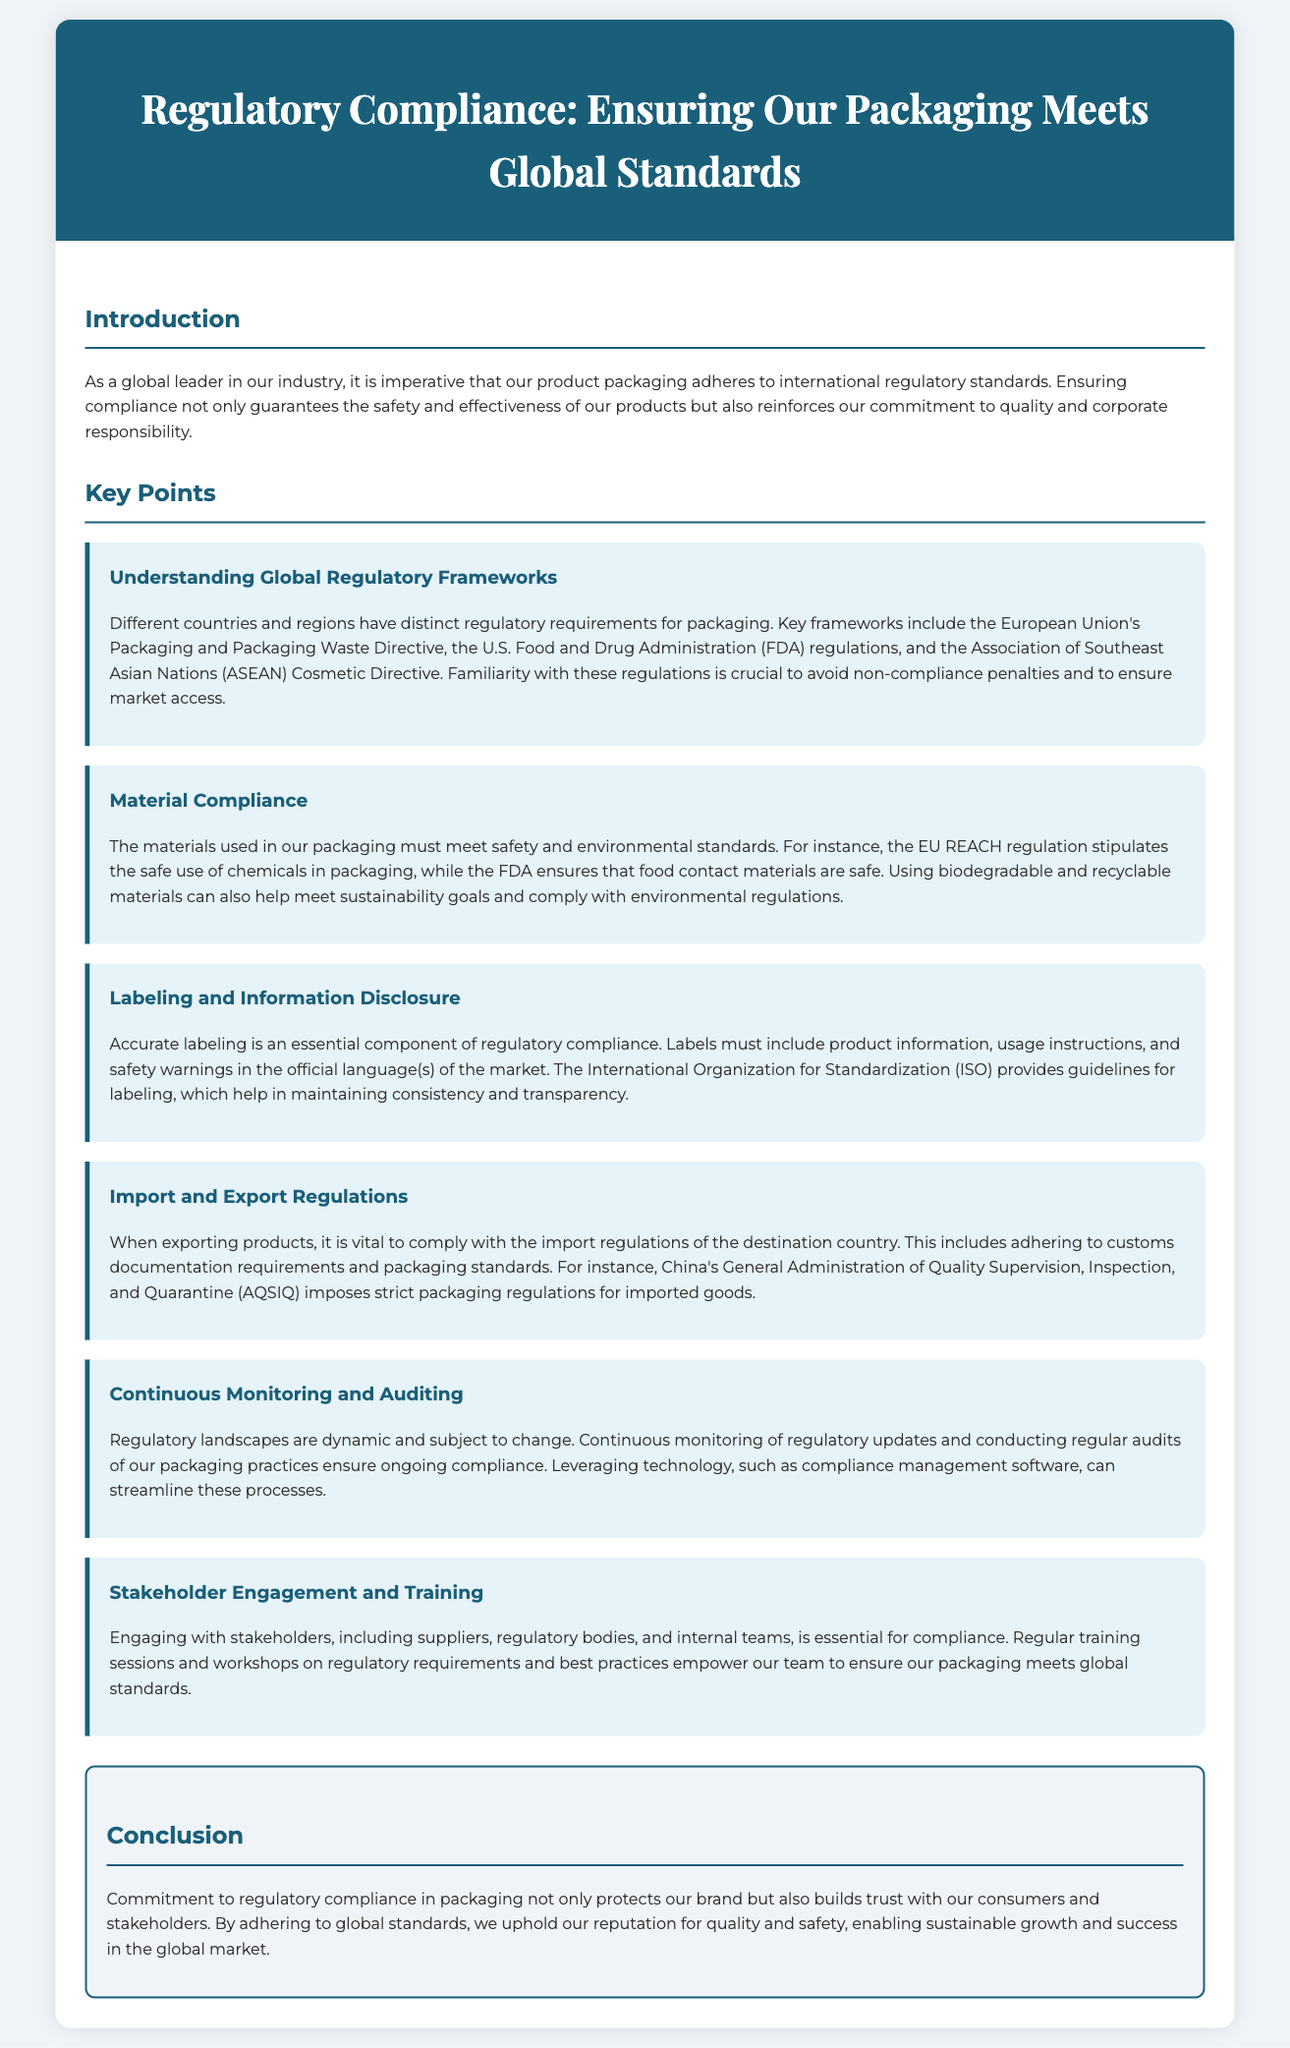What is the main purpose of regulatory compliance in packaging? The main purpose is to ensure our product packaging adheres to international regulatory standards, guaranteeing safety and effectiveness.
Answer: Ensuring safety and effectiveness What directives are mentioned in the document for packaging compliance? The document mentions the European Union's Packaging and Packaging Waste Directive, U.S. FDA regulations, and ASEAN Cosmetic Directive.
Answer: EU Packaging Directive, FDA regulations, ASEAN Cosmetic Directive Which regulation focuses on the safe use of chemicals in packaging? The EU REACH regulation focuses on the safe use of chemicals in packaging.
Answer: EU REACH regulation What is a critical requirement for accurate labeling? Accurate labeling must include product information, usage instructions, and safety warnings in the official language(s) of the market.
Answer: Official language(s) How often should we monitor regulatory updates? Continuous monitoring is required as regulatory landscapes are dynamic and subject to change.
Answer: Continuous What is a method suggested for ensuring ongoing compliance? Leveraging technology, such as compliance management software, can streamline the compliance processes.
Answer: Compliance management software What do regular training sessions aim to achieve? Regular training sessions aim to empower our team on regulatory requirements and best practices for compliance.
Answer: Empowering our team What is the ultimate benefit of committing to regulatory compliance in packaging? The ultimate benefit is building trust with consumers and stakeholders, protecting our brand.
Answer: Building trust 